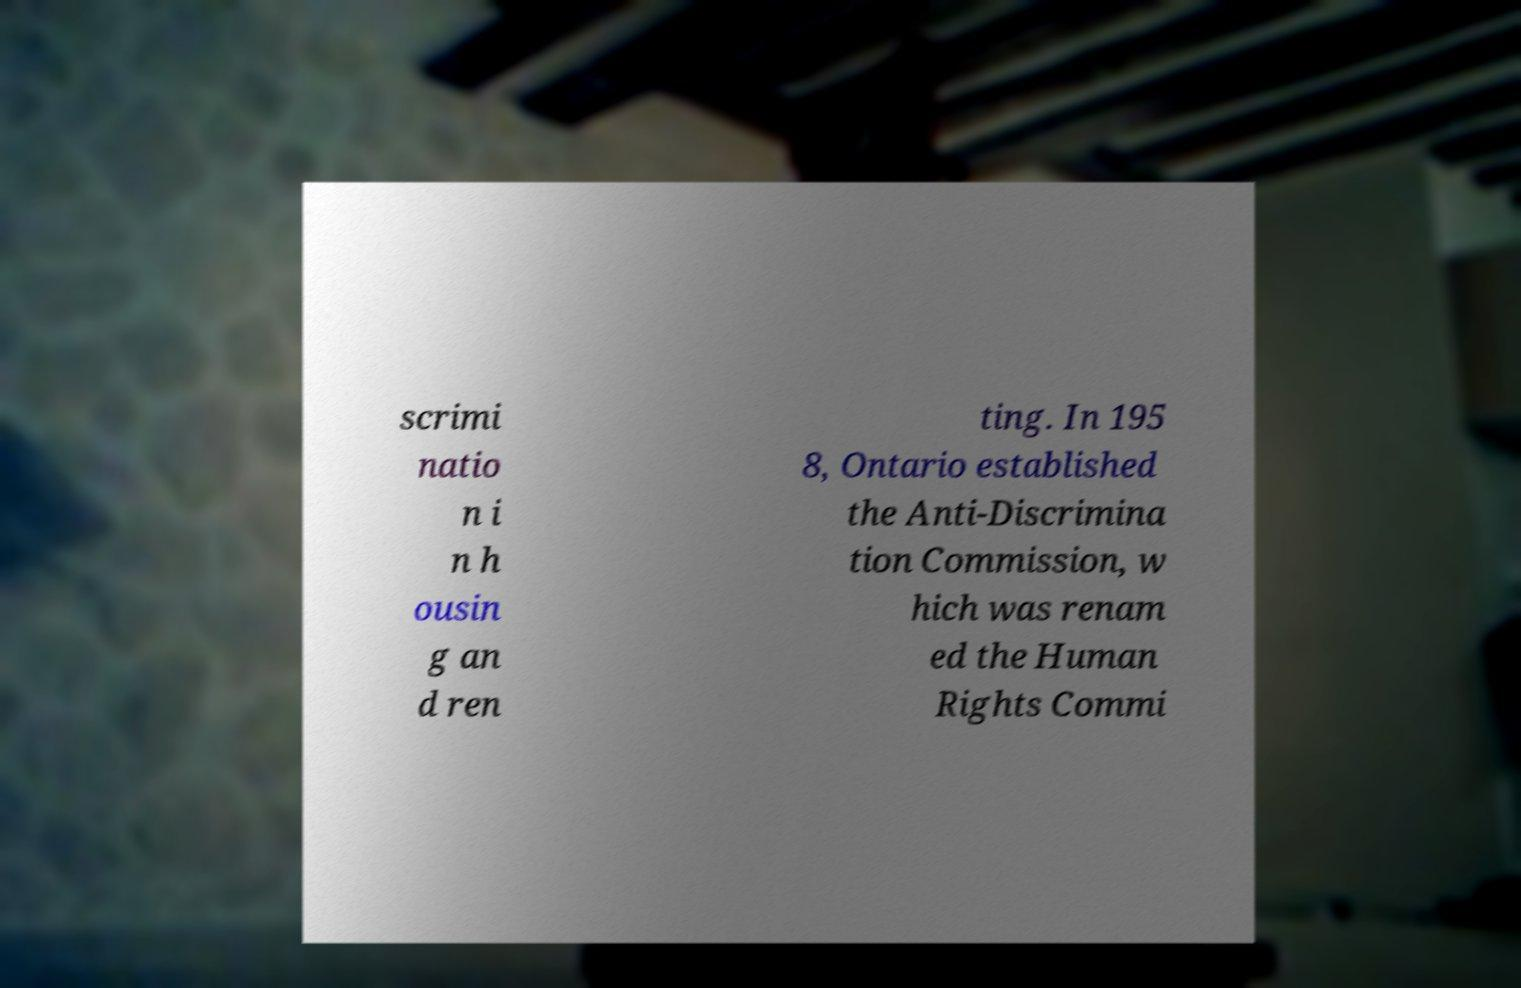I need the written content from this picture converted into text. Can you do that? scrimi natio n i n h ousin g an d ren ting. In 195 8, Ontario established the Anti-Discrimina tion Commission, w hich was renam ed the Human Rights Commi 